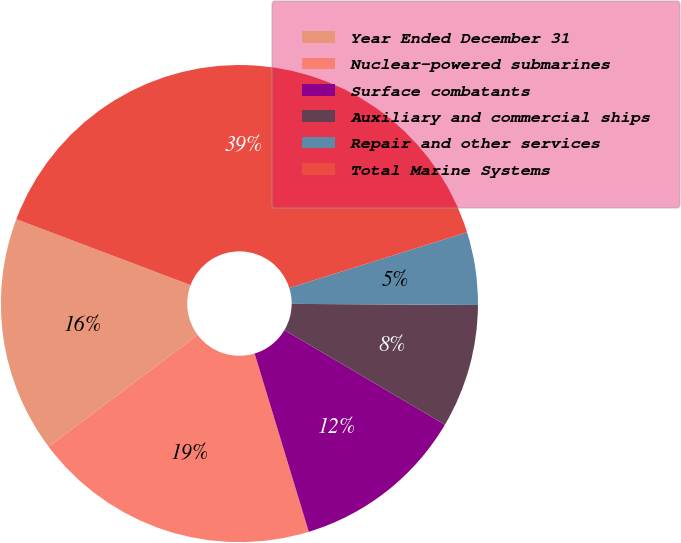Convert chart to OTSL. <chart><loc_0><loc_0><loc_500><loc_500><pie_chart><fcel>Year Ended December 31<fcel>Nuclear-powered submarines<fcel>Surface combatants<fcel>Auxiliary and commercial ships<fcel>Repair and other services<fcel>Total Marine Systems<nl><fcel>16.0%<fcel>19.45%<fcel>11.83%<fcel>8.38%<fcel>4.93%<fcel>39.41%<nl></chart> 